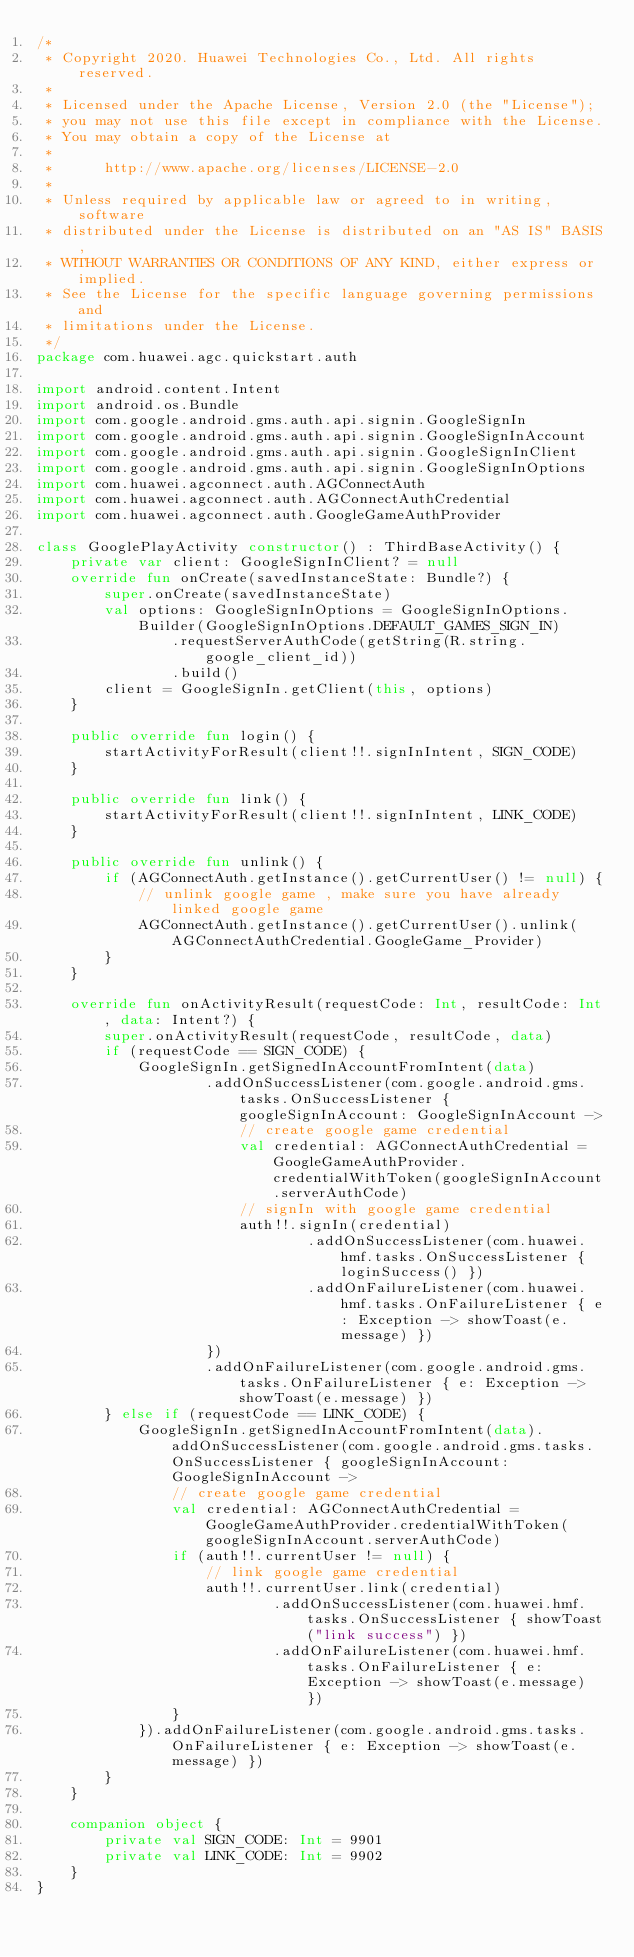Convert code to text. <code><loc_0><loc_0><loc_500><loc_500><_Kotlin_>/*
 * Copyright 2020. Huawei Technologies Co., Ltd. All rights reserved.
 *
 * Licensed under the Apache License, Version 2.0 (the "License");
 * you may not use this file except in compliance with the License.
 * You may obtain a copy of the License at
 *
 *      http://www.apache.org/licenses/LICENSE-2.0
 *
 * Unless required by applicable law or agreed to in writing, software
 * distributed under the License is distributed on an "AS IS" BASIS,
 * WITHOUT WARRANTIES OR CONDITIONS OF ANY KIND, either express or implied.
 * See the License for the specific language governing permissions and
 * limitations under the License.
 */
package com.huawei.agc.quickstart.auth

import android.content.Intent
import android.os.Bundle
import com.google.android.gms.auth.api.signin.GoogleSignIn
import com.google.android.gms.auth.api.signin.GoogleSignInAccount
import com.google.android.gms.auth.api.signin.GoogleSignInClient
import com.google.android.gms.auth.api.signin.GoogleSignInOptions
import com.huawei.agconnect.auth.AGConnectAuth
import com.huawei.agconnect.auth.AGConnectAuthCredential
import com.huawei.agconnect.auth.GoogleGameAuthProvider

class GooglePlayActivity constructor() : ThirdBaseActivity() {
    private var client: GoogleSignInClient? = null
    override fun onCreate(savedInstanceState: Bundle?) {
        super.onCreate(savedInstanceState)
        val options: GoogleSignInOptions = GoogleSignInOptions.Builder(GoogleSignInOptions.DEFAULT_GAMES_SIGN_IN)
                .requestServerAuthCode(getString(R.string.google_client_id))
                .build()
        client = GoogleSignIn.getClient(this, options)
    }

    public override fun login() {
        startActivityForResult(client!!.signInIntent, SIGN_CODE)
    }

    public override fun link() {
        startActivityForResult(client!!.signInIntent, LINK_CODE)
    }

    public override fun unlink() {
        if (AGConnectAuth.getInstance().getCurrentUser() != null) {
            // unlink google game , make sure you have already linked google game
            AGConnectAuth.getInstance().getCurrentUser().unlink(AGConnectAuthCredential.GoogleGame_Provider)
        }
    }

    override fun onActivityResult(requestCode: Int, resultCode: Int, data: Intent?) {
        super.onActivityResult(requestCode, resultCode, data)
        if (requestCode == SIGN_CODE) {
            GoogleSignIn.getSignedInAccountFromIntent(data)
                    .addOnSuccessListener(com.google.android.gms.tasks.OnSuccessListener { googleSignInAccount: GoogleSignInAccount ->
                        // create google game credential
                        val credential: AGConnectAuthCredential = GoogleGameAuthProvider.credentialWithToken(googleSignInAccount.serverAuthCode)
                        // signIn with google game credential
                        auth!!.signIn(credential)
                                .addOnSuccessListener(com.huawei.hmf.tasks.OnSuccessListener { loginSuccess() })
                                .addOnFailureListener(com.huawei.hmf.tasks.OnFailureListener { e: Exception -> showToast(e.message) })
                    })
                    .addOnFailureListener(com.google.android.gms.tasks.OnFailureListener { e: Exception -> showToast(e.message) })
        } else if (requestCode == LINK_CODE) {
            GoogleSignIn.getSignedInAccountFromIntent(data).addOnSuccessListener(com.google.android.gms.tasks.OnSuccessListener { googleSignInAccount: GoogleSignInAccount ->
                // create google game credential
                val credential: AGConnectAuthCredential = GoogleGameAuthProvider.credentialWithToken(googleSignInAccount.serverAuthCode)
                if (auth!!.currentUser != null) {
                    // link google game credential
                    auth!!.currentUser.link(credential)
                            .addOnSuccessListener(com.huawei.hmf.tasks.OnSuccessListener { showToast("link success") })
                            .addOnFailureListener(com.huawei.hmf.tasks.OnFailureListener { e: Exception -> showToast(e.message) })
                }
            }).addOnFailureListener(com.google.android.gms.tasks.OnFailureListener { e: Exception -> showToast(e.message) })
        }
    }

    companion object {
        private val SIGN_CODE: Int = 9901
        private val LINK_CODE: Int = 9902
    }
}</code> 